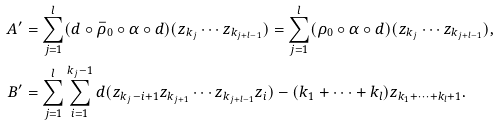Convert formula to latex. <formula><loc_0><loc_0><loc_500><loc_500>A ^ { \prime } & = \sum _ { j = 1 } ^ { l } ( d \circ \bar { \rho } _ { 0 } \circ \alpha \circ d ) ( z _ { k _ { j } } \cdots z _ { k _ { j + l - 1 } } ) = \sum _ { j = 1 } ^ { l } ( \rho _ { 0 } \circ \alpha \circ d ) ( z _ { k _ { j } } \cdots z _ { k _ { j + l - 1 } } ) , \\ B ^ { \prime } & = \sum _ { j = 1 } ^ { l } \sum _ { i = 1 } ^ { k _ { j } - 1 } d ( z _ { k _ { j } - i + 1 } z _ { k _ { j + 1 } } \cdots z _ { k _ { j + l - 1 } } z _ { i } ) - ( k _ { 1 } + \cdots + k _ { l } ) z _ { k _ { 1 } + \cdots + k _ { l } + 1 } .</formula> 